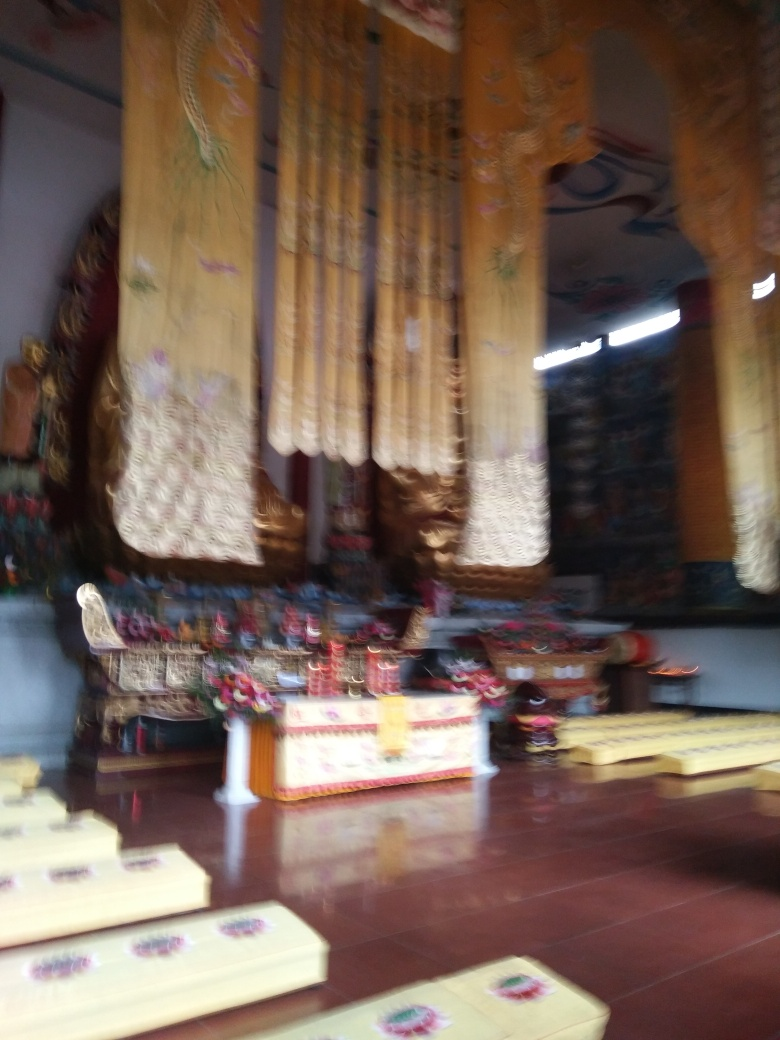Does the background reflect light? The image is quite blurry, which makes it challenging to provide a definitive answer about light reflection. However, based on what is visible, it appears that the background, most likely a wall or partition, has a semi-glossy surface which might reflect light under clearer conditions. 